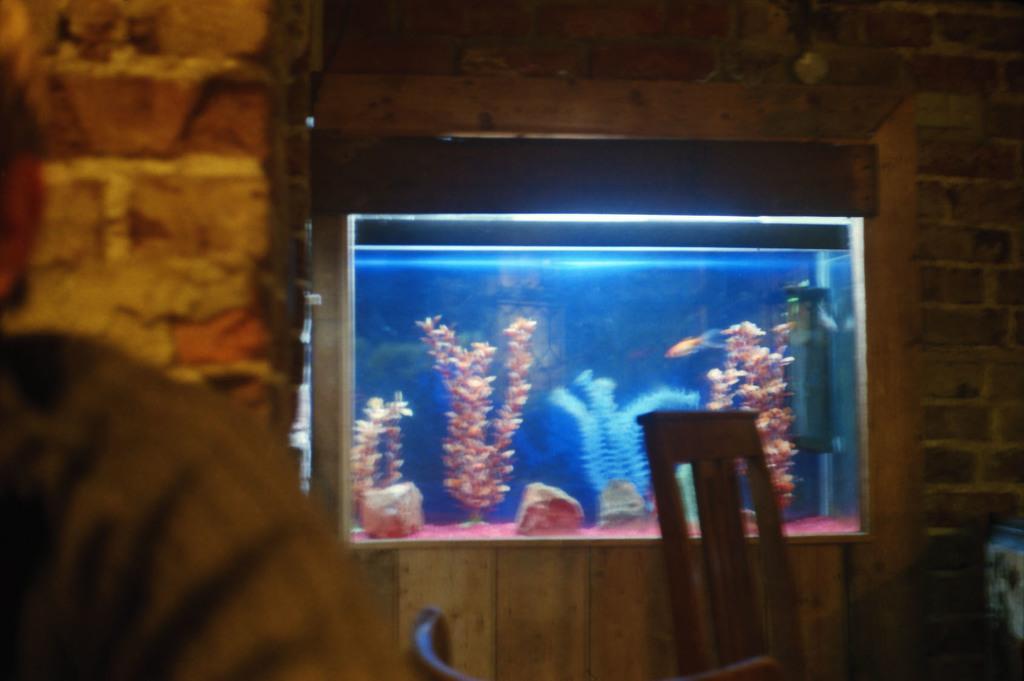Describe this image in one or two sentences. In this image on the left side there is one person, and in the center there is one aquarium. In that aquarium there are some water plants, and in the background there is a wall and some objects. 